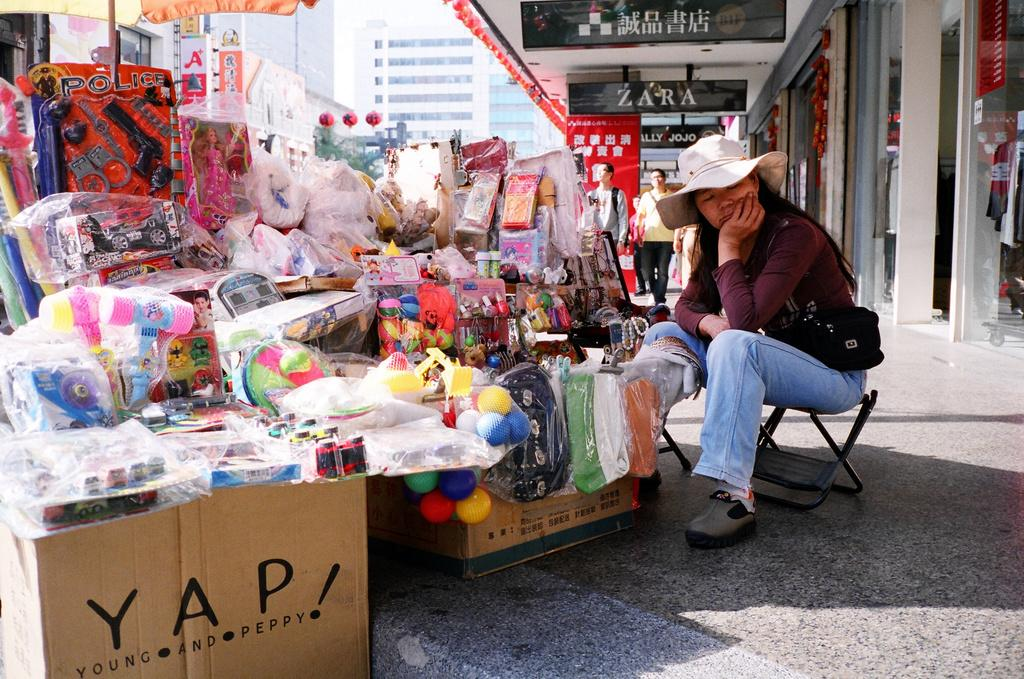What is the lady in the image doing? The lady is sitting on a chair in the image. What can be seen in front of the lady? There are objects in front of the lady. Can you identify any labels or names in the image? Yes, there are labels with the names "zara" and "jojo" in the image. How many clovers can be seen growing near the lady in the image? There are no clovers visible in the image. What is the lady's level of wealth based on the image? The image does not provide any information about the lady's wealth. 